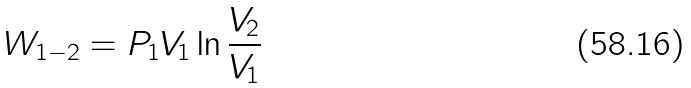<formula> <loc_0><loc_0><loc_500><loc_500>W _ { 1 - 2 } = P _ { 1 } V _ { 1 } \ln \frac { V _ { 2 } } { V _ { 1 } }</formula> 